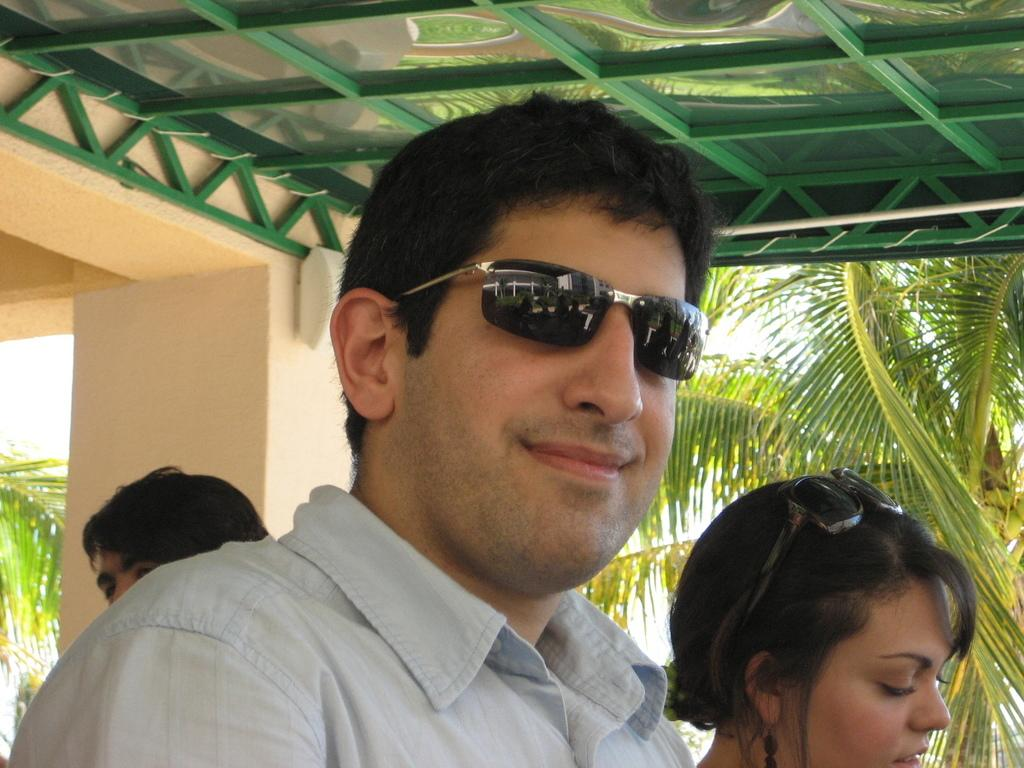Who or what is present in the image? There are people in the image. What can be seen above the people in the image? There is a ceiling visible at the top of the image. What architectural feature is visible in the background of the image? There is a pillar of a building in the background of the image. What type of natural scenery is visible in the background of the image? Trees are present in the background of the image. What type of machine can be seen flying in the sky in the image? There is no machine flying in the sky in the image; only people, a ceiling, a pillar of a building, and trees are present. 